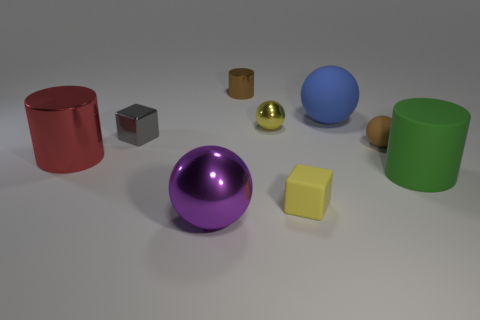Subtract all cyan balls. Subtract all brown cylinders. How many balls are left? 4 Subtract all cylinders. How many objects are left? 6 Add 7 blue shiny cylinders. How many blue shiny cylinders exist? 7 Subtract 0 yellow cylinders. How many objects are left? 9 Subtract all green shiny spheres. Subtract all cylinders. How many objects are left? 6 Add 1 blue matte spheres. How many blue matte spheres are left? 2 